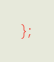<code> <loc_0><loc_0><loc_500><loc_500><_Haxe_>};
</code> 